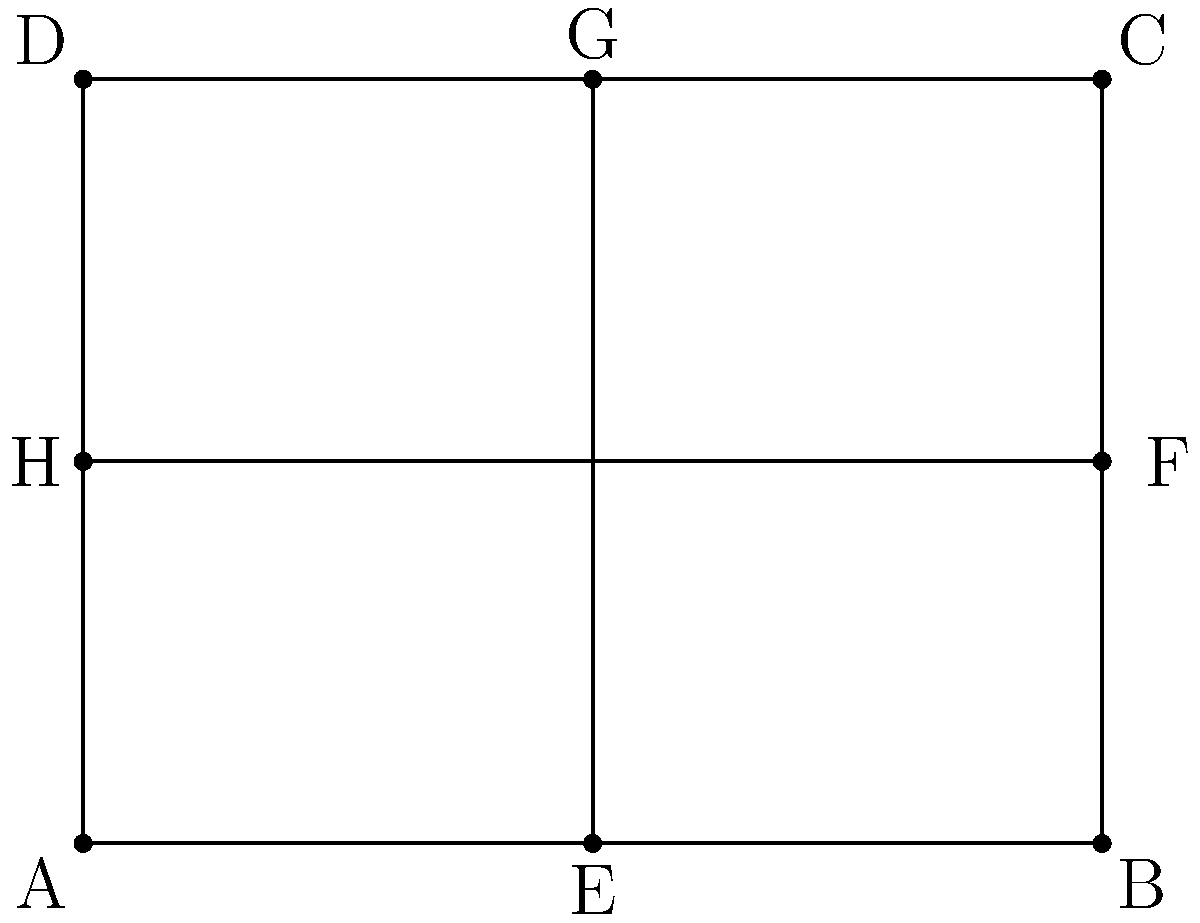At the Olentangy High School track, you notice a rectangular field with diagonal lines. If $\overline{EG}$ and $\overline{HF}$ are congruent line segments that intersect at the center of the rectangle $ABCD$, prove that $\triangle AEH \cong \triangle CGF$. Let's approach this step-by-step:

1) First, we know that $\overline{EG}$ and $\overline{HF}$ intersect at the center of the rectangle. This means that these diagonals bisect each other.

2) In a rectangle, diagonals are congruent and bisect each other. So, $\overline{EG} \cong \overline{HF}$.

3) Let's call the point of intersection O. Since O is the midpoint of both diagonals, we have:
   $EO \cong OG$ and $HO \cong OF$

4) In rectangle $ABCD$, we know that opposite sides are parallel and congruent. So:
   $\overline{AB} \parallel \overline{DC}$ and $\overline{AB} \cong \overline{DC}$
   $\overline{AD} \parallel \overline{BC}$ and $\overline{AD} \cong \overline{BC}$

5) Since E is the midpoint of $\overline{AB}$ and H is the midpoint of $\overline{AD}$:
   $AE \cong EB$ and $AH \cong HD$

6) Similarly, since G is the midpoint of $\overline{DC}$ and F is the midpoint of $\overline{BC}$:
   $CG \cong GD$ and $CF \cong FB$

7) Now, in $\triangle AEH$ and $\triangle CGF$:
   - $\angle EAH \cong \angle GCF$ (alternate interior angles, $\overline{AD} \parallel \overline{BC}$)
   - $AE \cong CG$ (halves of congruent sides $\overline{AB}$ and $\overline{DC}$)
   - $AH \cong CF$ (halves of congruent sides $\overline{AD}$ and $\overline{BC}$)

8) By the SAS (Side-Angle-Side) congruence criterion, $\triangle AEH \cong \triangle CGF$.
Answer: $\triangle AEH \cong \triangle CGF$ by SAS 